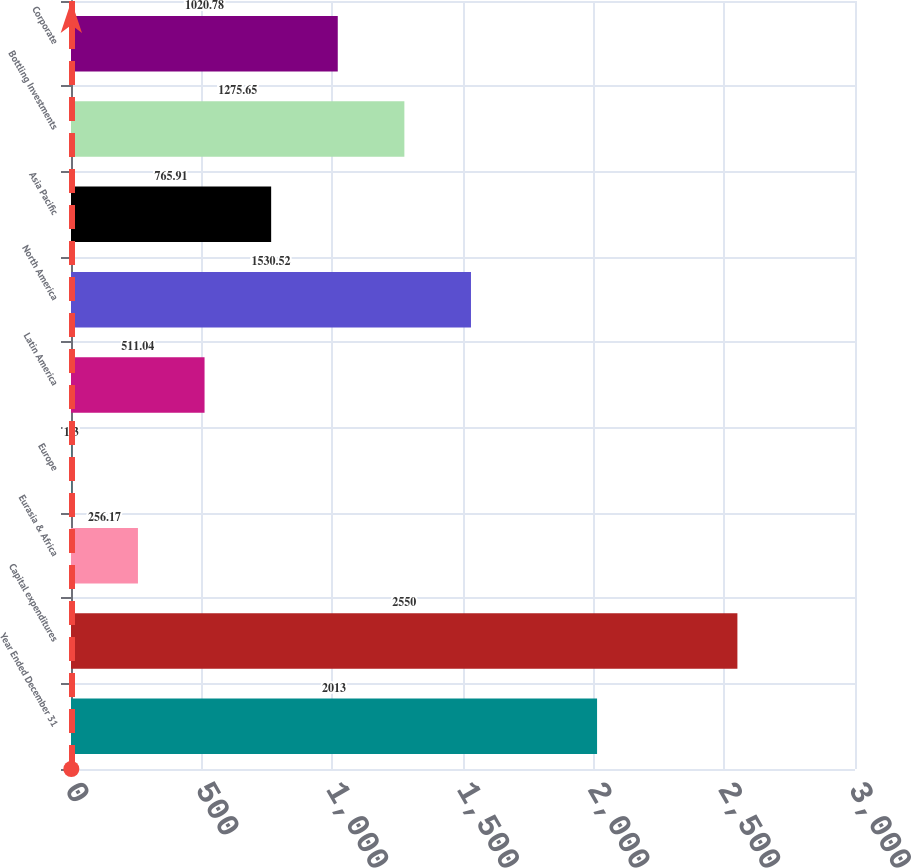Convert chart to OTSL. <chart><loc_0><loc_0><loc_500><loc_500><bar_chart><fcel>Year Ended December 31<fcel>Capital expenditures<fcel>Eurasia & Africa<fcel>Europe<fcel>Latin America<fcel>North America<fcel>Asia Pacific<fcel>Bottling Investments<fcel>Corporate<nl><fcel>2013<fcel>2550<fcel>256.17<fcel>1.3<fcel>511.04<fcel>1530.52<fcel>765.91<fcel>1275.65<fcel>1020.78<nl></chart> 